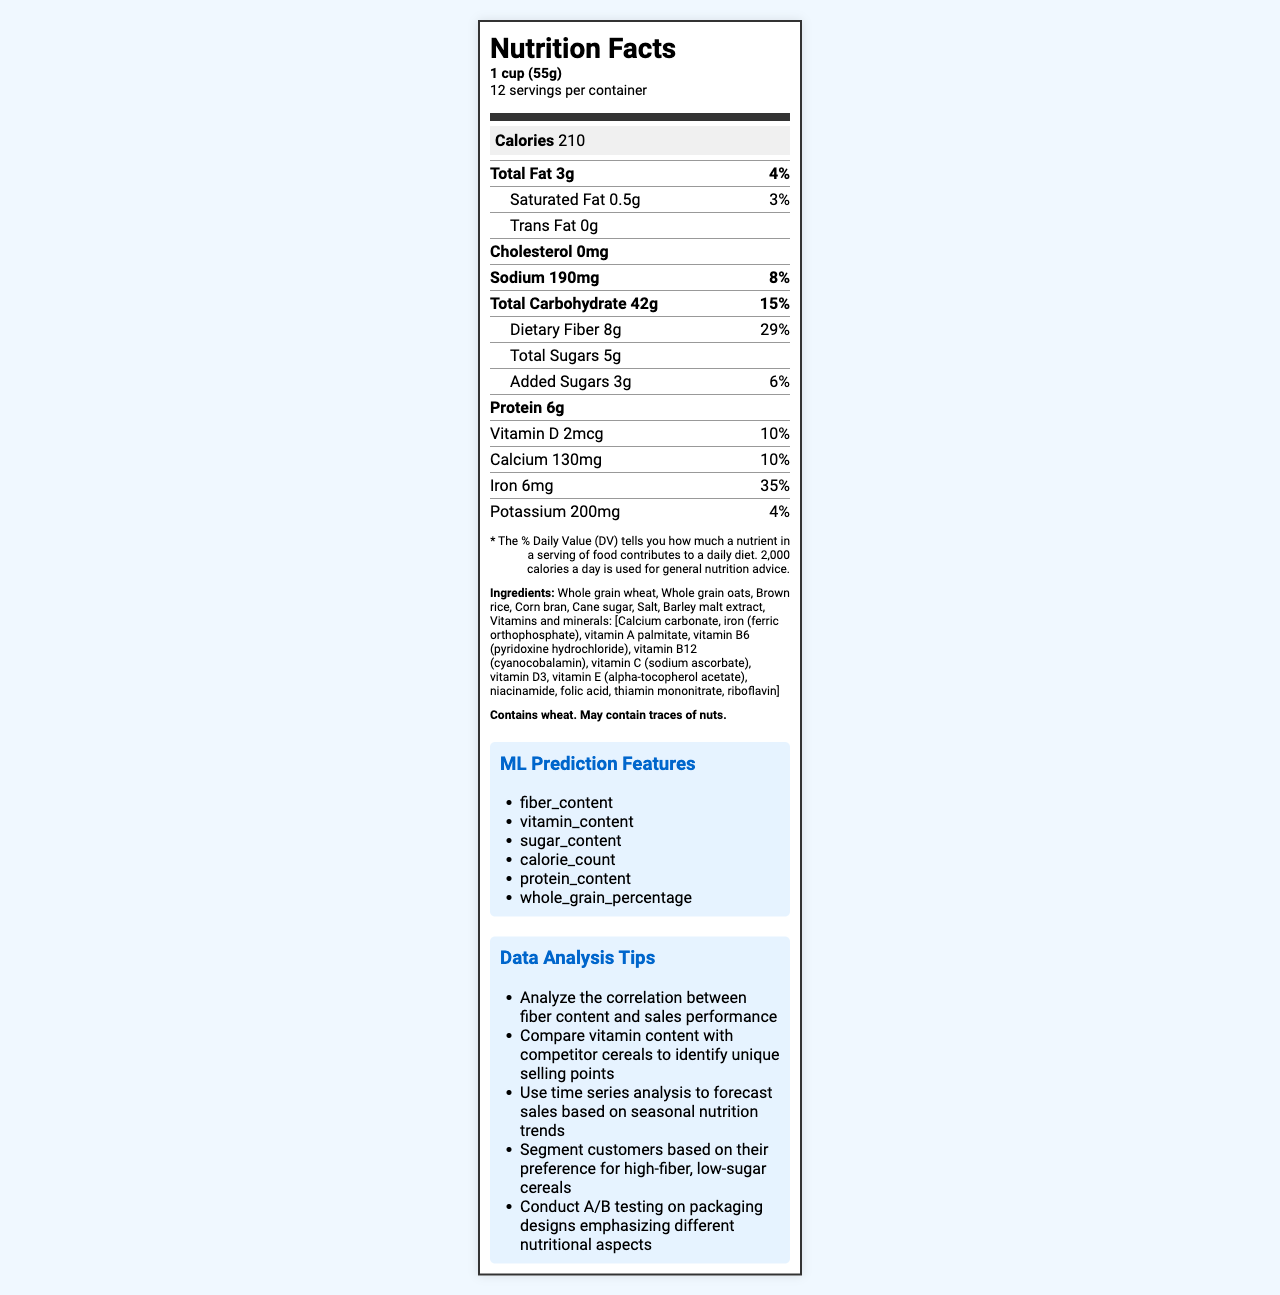how many servings are in one container? According to the document, each container has 12 servings.
Answer: 12 What is the serving size for FiberBoost Whole Grain Cereal? The serving size is listed as "1 cup (55g)" in the document.
Answer: 1 cup (55g) What amount of dietary fiber is present in one serving, and what is its daily value percentage? The document states that one serving contains 8g of dietary fiber, which contributes to 29% of the daily value.
Answer: 8g, 29% Which vitamins have a daily value contribution of 25% in the cereal? A. Vitamin D, Calcium, Iron B. Thiamin, Riboflavin, Niacin, Vitamin B6, Folate, Vitamin B12 C. Vitamin A, Vitamin C, Vitamin E The document specifies that Thiamin, Riboflavin, Niacin, Vitamin B6, Folate, and Vitamin B12 each contribute 25% to the daily value.
Answer: B Does the cereal contain any trans fat? The document indicates that the amount of trans fat is 0g.
Answer: No What is the calorie count per serving of FiberBoost Whole Grain Cereal? The document lists the calorie count as 210 per serving.
Answer: 210 What are the main ingredients of the cereal? The primary ingredients are listed directly under the "Ingredients" section of the document.
Answer: Whole grain wheat, Whole grain oats, Brown rice, Corn bran, Cane sugar, Salt, Barley malt extract, Vitamins and minerals Which nutrient has the highest daily value percentage in the cereal? A. Iron B. Dietary Fiber C. Sodium D. Vitamin C Iron has a daily value percentage of 35%, which is higher than any other nutrient listed.
Answer: A Does the product contain any allergens? The document specifies that the product contains wheat and may contain traces of nuts.
Answer: Yes Summarize the main idea of the document. The document compiles comprehensive nutritional information about the whole grain cereal, including quantities of various nutrients, serving facts, ingredient breakdown, and additional insights for data analysis and machine learning.
Answer: The document provides the nutrition facts for FiberBoost Whole Grain Cereal, detailing serving size, calories, fat, carbohydrates, protein, vitamins, minerals, ingredients, and allergen information. It also suggests features for machine learning prediction and data analysis tips related to product sales. Are the vitamins and minerals naturally occurring or added? The document does not provide information regarding the source of the vitamins and minerals, whether they are naturally occurring or added.
Answer: Cannot be determined 